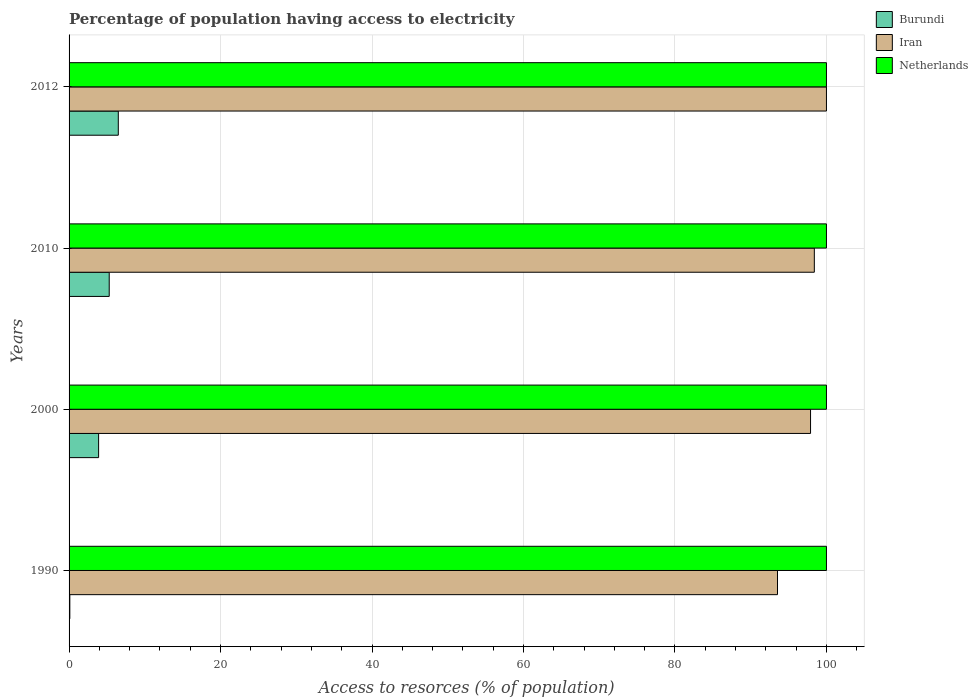How many different coloured bars are there?
Offer a very short reply. 3. How many groups of bars are there?
Provide a short and direct response. 4. Are the number of bars per tick equal to the number of legend labels?
Make the answer very short. Yes. Are the number of bars on each tick of the Y-axis equal?
Keep it short and to the point. Yes. What is the percentage of population having access to electricity in Iran in 2000?
Give a very brief answer. 97.9. Across all years, what is the maximum percentage of population having access to electricity in Iran?
Give a very brief answer. 100. Across all years, what is the minimum percentage of population having access to electricity in Netherlands?
Provide a short and direct response. 100. What is the total percentage of population having access to electricity in Burundi in the graph?
Offer a terse response. 15.8. What is the difference between the percentage of population having access to electricity in Burundi in 2010 and that in 2012?
Provide a short and direct response. -1.2. What is the difference between the percentage of population having access to electricity in Burundi in 2000 and the percentage of population having access to electricity in Netherlands in 2012?
Ensure brevity in your answer.  -96.1. What is the average percentage of population having access to electricity in Netherlands per year?
Provide a succinct answer. 100. In the year 1990, what is the difference between the percentage of population having access to electricity in Iran and percentage of population having access to electricity in Netherlands?
Offer a very short reply. -6.46. Is the difference between the percentage of population having access to electricity in Iran in 2000 and 2010 greater than the difference between the percentage of population having access to electricity in Netherlands in 2000 and 2010?
Keep it short and to the point. No. What is the difference between the highest and the second highest percentage of population having access to electricity in Iran?
Provide a succinct answer. 1.6. What is the difference between the highest and the lowest percentage of population having access to electricity in Iran?
Ensure brevity in your answer.  6.46. In how many years, is the percentage of population having access to electricity in Iran greater than the average percentage of population having access to electricity in Iran taken over all years?
Your answer should be very brief. 3. What does the 2nd bar from the top in 2012 represents?
Your answer should be compact. Iran. What does the 1st bar from the bottom in 2012 represents?
Provide a short and direct response. Burundi. Is it the case that in every year, the sum of the percentage of population having access to electricity in Netherlands and percentage of population having access to electricity in Burundi is greater than the percentage of population having access to electricity in Iran?
Provide a short and direct response. Yes. Are all the bars in the graph horizontal?
Offer a terse response. Yes. Does the graph contain any zero values?
Your answer should be very brief. No. How are the legend labels stacked?
Keep it short and to the point. Vertical. What is the title of the graph?
Your answer should be compact. Percentage of population having access to electricity. Does "Uganda" appear as one of the legend labels in the graph?
Keep it short and to the point. No. What is the label or title of the X-axis?
Your answer should be compact. Access to resorces (% of population). What is the Access to resorces (% of population) in Burundi in 1990?
Keep it short and to the point. 0.1. What is the Access to resorces (% of population) in Iran in 1990?
Make the answer very short. 93.54. What is the Access to resorces (% of population) of Netherlands in 1990?
Your answer should be compact. 100. What is the Access to resorces (% of population) in Iran in 2000?
Provide a short and direct response. 97.9. What is the Access to resorces (% of population) in Netherlands in 2000?
Ensure brevity in your answer.  100. What is the Access to resorces (% of population) in Iran in 2010?
Your answer should be compact. 98.4. What is the Access to resorces (% of population) in Netherlands in 2010?
Give a very brief answer. 100. What is the Access to resorces (% of population) in Netherlands in 2012?
Your answer should be compact. 100. Across all years, what is the maximum Access to resorces (% of population) of Iran?
Provide a short and direct response. 100. Across all years, what is the maximum Access to resorces (% of population) in Netherlands?
Provide a succinct answer. 100. Across all years, what is the minimum Access to resorces (% of population) in Iran?
Ensure brevity in your answer.  93.54. Across all years, what is the minimum Access to resorces (% of population) in Netherlands?
Offer a terse response. 100. What is the total Access to resorces (% of population) of Burundi in the graph?
Offer a terse response. 15.8. What is the total Access to resorces (% of population) of Iran in the graph?
Your response must be concise. 389.84. What is the total Access to resorces (% of population) of Netherlands in the graph?
Your answer should be very brief. 400. What is the difference between the Access to resorces (% of population) in Burundi in 1990 and that in 2000?
Your answer should be compact. -3.8. What is the difference between the Access to resorces (% of population) in Iran in 1990 and that in 2000?
Offer a very short reply. -4.36. What is the difference between the Access to resorces (% of population) of Netherlands in 1990 and that in 2000?
Provide a succinct answer. 0. What is the difference between the Access to resorces (% of population) in Burundi in 1990 and that in 2010?
Give a very brief answer. -5.2. What is the difference between the Access to resorces (% of population) of Iran in 1990 and that in 2010?
Offer a terse response. -4.86. What is the difference between the Access to resorces (% of population) of Iran in 1990 and that in 2012?
Make the answer very short. -6.46. What is the difference between the Access to resorces (% of population) of Burundi in 2000 and that in 2012?
Keep it short and to the point. -2.6. What is the difference between the Access to resorces (% of population) of Iran in 2000 and that in 2012?
Ensure brevity in your answer.  -2.1. What is the difference between the Access to resorces (% of population) in Netherlands in 2000 and that in 2012?
Ensure brevity in your answer.  0. What is the difference between the Access to resorces (% of population) of Iran in 2010 and that in 2012?
Make the answer very short. -1.6. What is the difference between the Access to resorces (% of population) in Netherlands in 2010 and that in 2012?
Offer a very short reply. 0. What is the difference between the Access to resorces (% of population) in Burundi in 1990 and the Access to resorces (% of population) in Iran in 2000?
Provide a short and direct response. -97.8. What is the difference between the Access to resorces (% of population) of Burundi in 1990 and the Access to resorces (% of population) of Netherlands in 2000?
Keep it short and to the point. -99.9. What is the difference between the Access to resorces (% of population) of Iran in 1990 and the Access to resorces (% of population) of Netherlands in 2000?
Keep it short and to the point. -6.46. What is the difference between the Access to resorces (% of population) in Burundi in 1990 and the Access to resorces (% of population) in Iran in 2010?
Give a very brief answer. -98.3. What is the difference between the Access to resorces (% of population) of Burundi in 1990 and the Access to resorces (% of population) of Netherlands in 2010?
Keep it short and to the point. -99.9. What is the difference between the Access to resorces (% of population) in Iran in 1990 and the Access to resorces (% of population) in Netherlands in 2010?
Provide a succinct answer. -6.46. What is the difference between the Access to resorces (% of population) in Burundi in 1990 and the Access to resorces (% of population) in Iran in 2012?
Ensure brevity in your answer.  -99.9. What is the difference between the Access to resorces (% of population) in Burundi in 1990 and the Access to resorces (% of population) in Netherlands in 2012?
Offer a terse response. -99.9. What is the difference between the Access to resorces (% of population) in Iran in 1990 and the Access to resorces (% of population) in Netherlands in 2012?
Make the answer very short. -6.46. What is the difference between the Access to resorces (% of population) of Burundi in 2000 and the Access to resorces (% of population) of Iran in 2010?
Make the answer very short. -94.5. What is the difference between the Access to resorces (% of population) in Burundi in 2000 and the Access to resorces (% of population) in Netherlands in 2010?
Offer a very short reply. -96.1. What is the difference between the Access to resorces (% of population) in Iran in 2000 and the Access to resorces (% of population) in Netherlands in 2010?
Provide a short and direct response. -2.1. What is the difference between the Access to resorces (% of population) in Burundi in 2000 and the Access to resorces (% of population) in Iran in 2012?
Keep it short and to the point. -96.1. What is the difference between the Access to resorces (% of population) in Burundi in 2000 and the Access to resorces (% of population) in Netherlands in 2012?
Make the answer very short. -96.1. What is the difference between the Access to resorces (% of population) in Burundi in 2010 and the Access to resorces (% of population) in Iran in 2012?
Make the answer very short. -94.7. What is the difference between the Access to resorces (% of population) in Burundi in 2010 and the Access to resorces (% of population) in Netherlands in 2012?
Offer a very short reply. -94.7. What is the average Access to resorces (% of population) in Burundi per year?
Give a very brief answer. 3.95. What is the average Access to resorces (% of population) in Iran per year?
Make the answer very short. 97.46. In the year 1990, what is the difference between the Access to resorces (% of population) in Burundi and Access to resorces (% of population) in Iran?
Provide a succinct answer. -93.44. In the year 1990, what is the difference between the Access to resorces (% of population) of Burundi and Access to resorces (% of population) of Netherlands?
Make the answer very short. -99.9. In the year 1990, what is the difference between the Access to resorces (% of population) of Iran and Access to resorces (% of population) of Netherlands?
Provide a succinct answer. -6.46. In the year 2000, what is the difference between the Access to resorces (% of population) of Burundi and Access to resorces (% of population) of Iran?
Offer a very short reply. -94. In the year 2000, what is the difference between the Access to resorces (% of population) in Burundi and Access to resorces (% of population) in Netherlands?
Provide a succinct answer. -96.1. In the year 2010, what is the difference between the Access to resorces (% of population) of Burundi and Access to resorces (% of population) of Iran?
Provide a short and direct response. -93.1. In the year 2010, what is the difference between the Access to resorces (% of population) in Burundi and Access to resorces (% of population) in Netherlands?
Your answer should be compact. -94.7. In the year 2010, what is the difference between the Access to resorces (% of population) of Iran and Access to resorces (% of population) of Netherlands?
Provide a succinct answer. -1.6. In the year 2012, what is the difference between the Access to resorces (% of population) of Burundi and Access to resorces (% of population) of Iran?
Give a very brief answer. -93.5. In the year 2012, what is the difference between the Access to resorces (% of population) in Burundi and Access to resorces (% of population) in Netherlands?
Offer a very short reply. -93.5. In the year 2012, what is the difference between the Access to resorces (% of population) of Iran and Access to resorces (% of population) of Netherlands?
Your answer should be very brief. 0. What is the ratio of the Access to resorces (% of population) in Burundi in 1990 to that in 2000?
Your answer should be very brief. 0.03. What is the ratio of the Access to resorces (% of population) in Iran in 1990 to that in 2000?
Make the answer very short. 0.96. What is the ratio of the Access to resorces (% of population) of Netherlands in 1990 to that in 2000?
Your answer should be compact. 1. What is the ratio of the Access to resorces (% of population) in Burundi in 1990 to that in 2010?
Your answer should be compact. 0.02. What is the ratio of the Access to resorces (% of population) in Iran in 1990 to that in 2010?
Your answer should be very brief. 0.95. What is the ratio of the Access to resorces (% of population) in Netherlands in 1990 to that in 2010?
Make the answer very short. 1. What is the ratio of the Access to resorces (% of population) in Burundi in 1990 to that in 2012?
Your response must be concise. 0.02. What is the ratio of the Access to resorces (% of population) of Iran in 1990 to that in 2012?
Your answer should be compact. 0.94. What is the ratio of the Access to resorces (% of population) in Netherlands in 1990 to that in 2012?
Keep it short and to the point. 1. What is the ratio of the Access to resorces (% of population) in Burundi in 2000 to that in 2010?
Offer a very short reply. 0.74. What is the ratio of the Access to resorces (% of population) of Netherlands in 2000 to that in 2010?
Provide a succinct answer. 1. What is the ratio of the Access to resorces (% of population) in Burundi in 2010 to that in 2012?
Offer a very short reply. 0.82. What is the ratio of the Access to resorces (% of population) of Iran in 2010 to that in 2012?
Offer a terse response. 0.98. What is the difference between the highest and the second highest Access to resorces (% of population) of Burundi?
Your answer should be compact. 1.2. What is the difference between the highest and the second highest Access to resorces (% of population) in Netherlands?
Give a very brief answer. 0. What is the difference between the highest and the lowest Access to resorces (% of population) of Iran?
Your answer should be very brief. 6.46. 